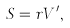Convert formula to latex. <formula><loc_0><loc_0><loc_500><loc_500>S = r V ^ { \prime } ,</formula> 